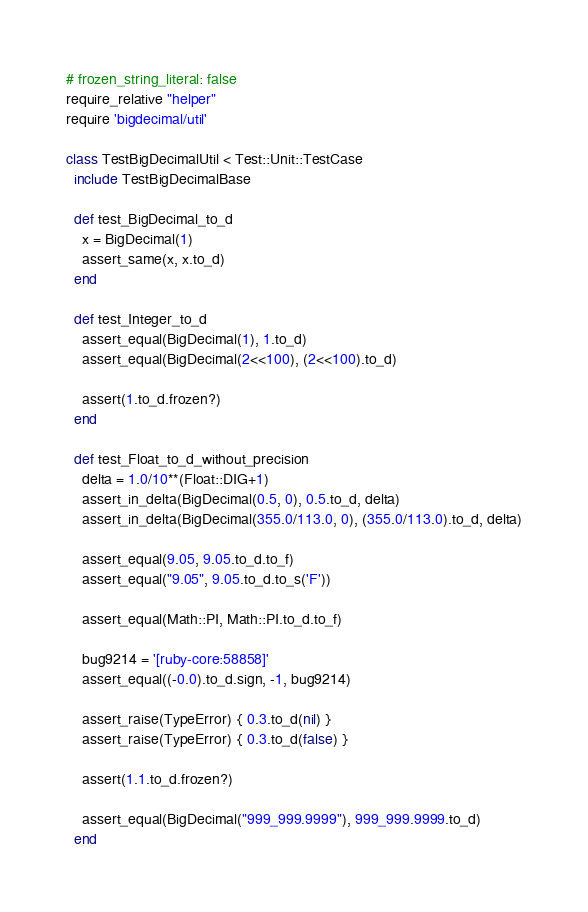<code> <loc_0><loc_0><loc_500><loc_500><_Ruby_># frozen_string_literal: false
require_relative "helper"
require 'bigdecimal/util'

class TestBigDecimalUtil < Test::Unit::TestCase
  include TestBigDecimalBase

  def test_BigDecimal_to_d
    x = BigDecimal(1)
    assert_same(x, x.to_d)
  end

  def test_Integer_to_d
    assert_equal(BigDecimal(1), 1.to_d)
    assert_equal(BigDecimal(2<<100), (2<<100).to_d)

    assert(1.to_d.frozen?)
  end

  def test_Float_to_d_without_precision
    delta = 1.0/10**(Float::DIG+1)
    assert_in_delta(BigDecimal(0.5, 0), 0.5.to_d, delta)
    assert_in_delta(BigDecimal(355.0/113.0, 0), (355.0/113.0).to_d, delta)

    assert_equal(9.05, 9.05.to_d.to_f)
    assert_equal("9.05", 9.05.to_d.to_s('F'))

    assert_equal(Math::PI, Math::PI.to_d.to_f)

    bug9214 = '[ruby-core:58858]'
    assert_equal((-0.0).to_d.sign, -1, bug9214)

    assert_raise(TypeError) { 0.3.to_d(nil) }
    assert_raise(TypeError) { 0.3.to_d(false) }

    assert(1.1.to_d.frozen?)

    assert_equal(BigDecimal("999_999.9999"), 999_999.9999.to_d)
  end
</code> 